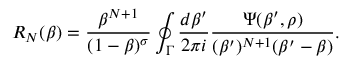Convert formula to latex. <formula><loc_0><loc_0><loc_500><loc_500>R _ { N } ( \beta ) = { \frac { \beta ^ { N + 1 } } { ( 1 - \beta ) ^ { \sigma } } } \oint _ { \Gamma } { \frac { d \beta ^ { \prime } } { 2 \pi i } } { \frac { \Psi ( \beta ^ { \prime } , \rho ) } { ( \beta ^ { \prime } ) ^ { N + 1 } ( \beta ^ { \prime } - \beta ) } } .</formula> 